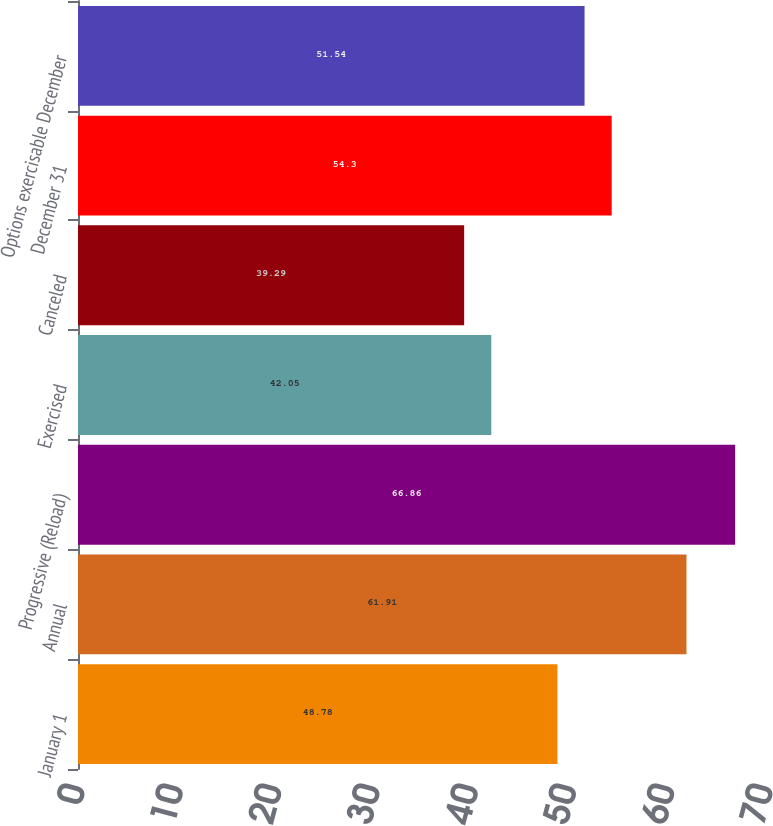<chart> <loc_0><loc_0><loc_500><loc_500><bar_chart><fcel>January 1<fcel>Annual<fcel>Progressive (Reload)<fcel>Exercised<fcel>Canceled<fcel>December 31<fcel>Options exercisable December<nl><fcel>48.78<fcel>61.91<fcel>66.86<fcel>42.05<fcel>39.29<fcel>54.3<fcel>51.54<nl></chart> 